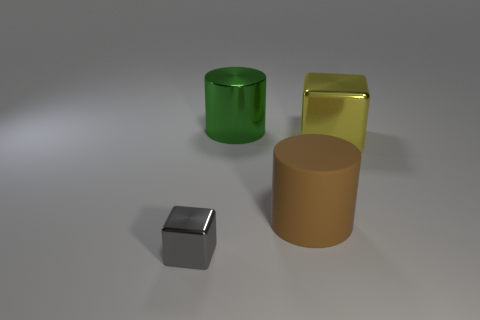Add 4 large purple matte cubes. How many objects exist? 8 Subtract 1 cylinders. How many cylinders are left? 1 Subtract all green cylinders. How many cylinders are left? 1 Subtract all brown cylinders. How many yellow cubes are left? 1 Subtract all blue metallic blocks. Subtract all blocks. How many objects are left? 2 Add 2 tiny metallic objects. How many tiny metallic objects are left? 3 Add 2 big purple metallic spheres. How many big purple metallic spheres exist? 2 Subtract 0 green cubes. How many objects are left? 4 Subtract all brown cylinders. Subtract all brown blocks. How many cylinders are left? 1 